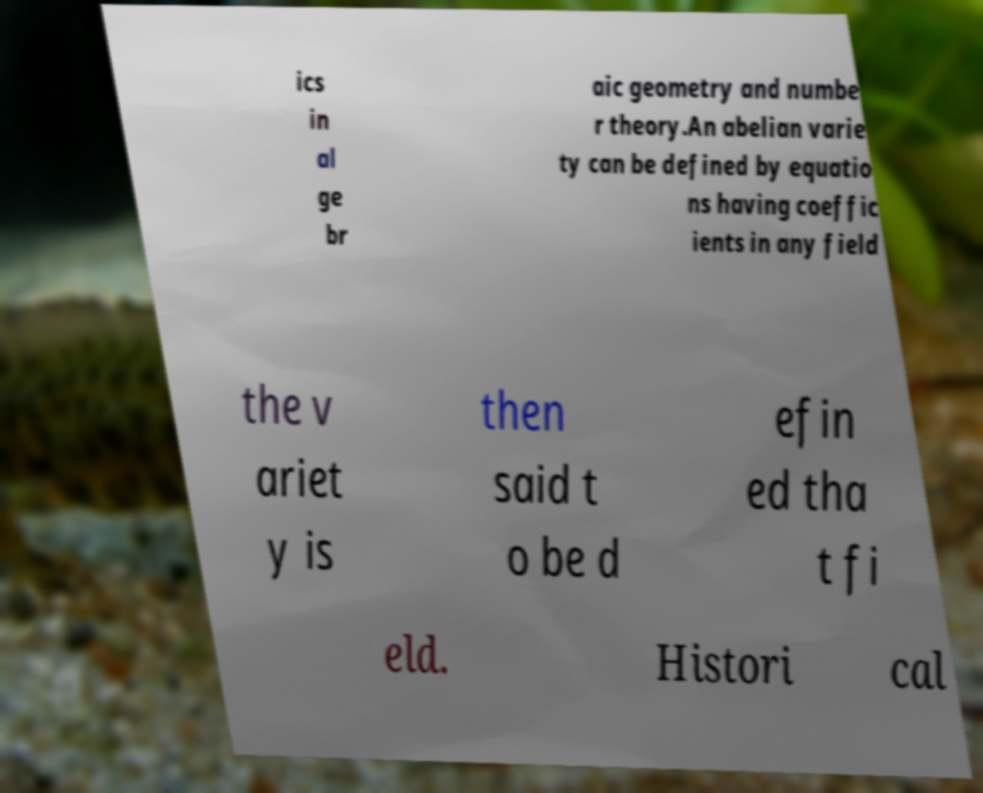What messages or text are displayed in this image? I need them in a readable, typed format. ics in al ge br aic geometry and numbe r theory.An abelian varie ty can be defined by equatio ns having coeffic ients in any field the v ariet y is then said t o be d efin ed tha t fi eld. Histori cal 